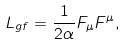<formula> <loc_0><loc_0><loc_500><loc_500>L _ { g f } = \frac { 1 } { 2 \alpha } F _ { \mu } F ^ { \mu } ,</formula> 